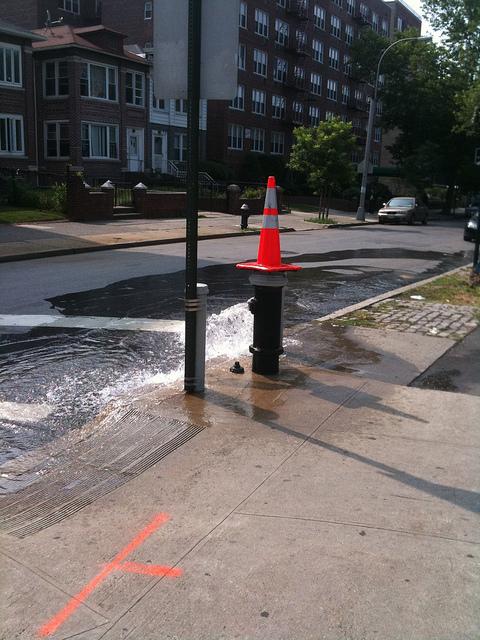What are the orange cones for?
Concise answer only. Safety. Is this for tourists?
Quick response, please. No. What does the cone on top of the fire hydrant indicate?
Be succinct. Caution. What color is the cone?
Give a very brief answer. Orange. Is the water spilling out into the street?
Give a very brief answer. Yes. Is the fire hydrant dripping?
Quick response, please. Yes. Is this a street corner?
Write a very short answer. No. 